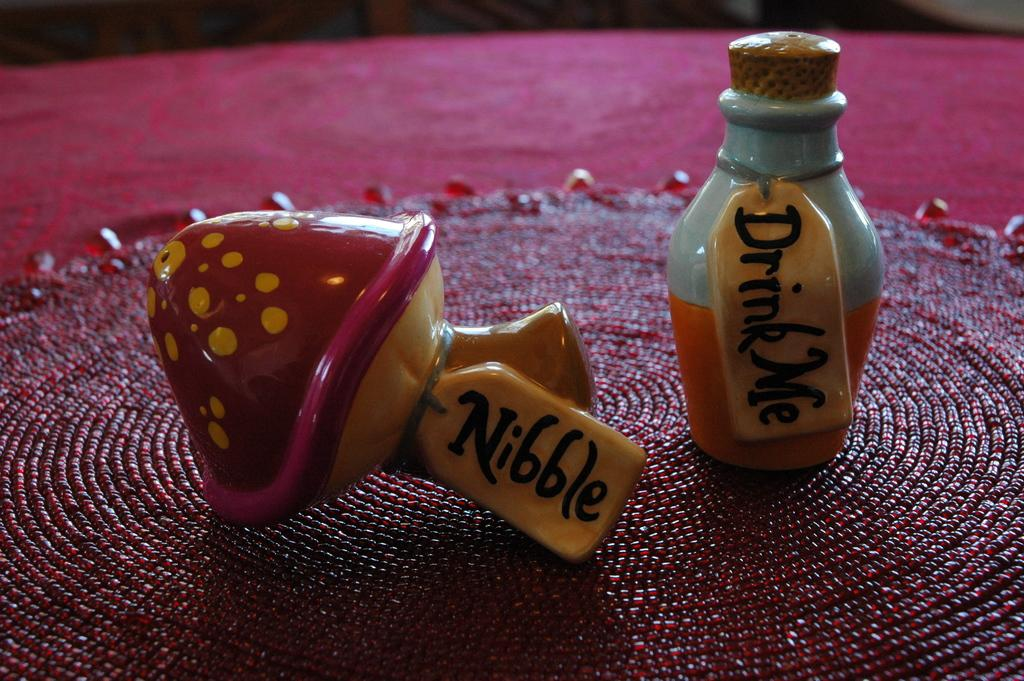<image>
Relay a brief, clear account of the picture shown. Hand made drink me bottle and mushroom that says nibble 